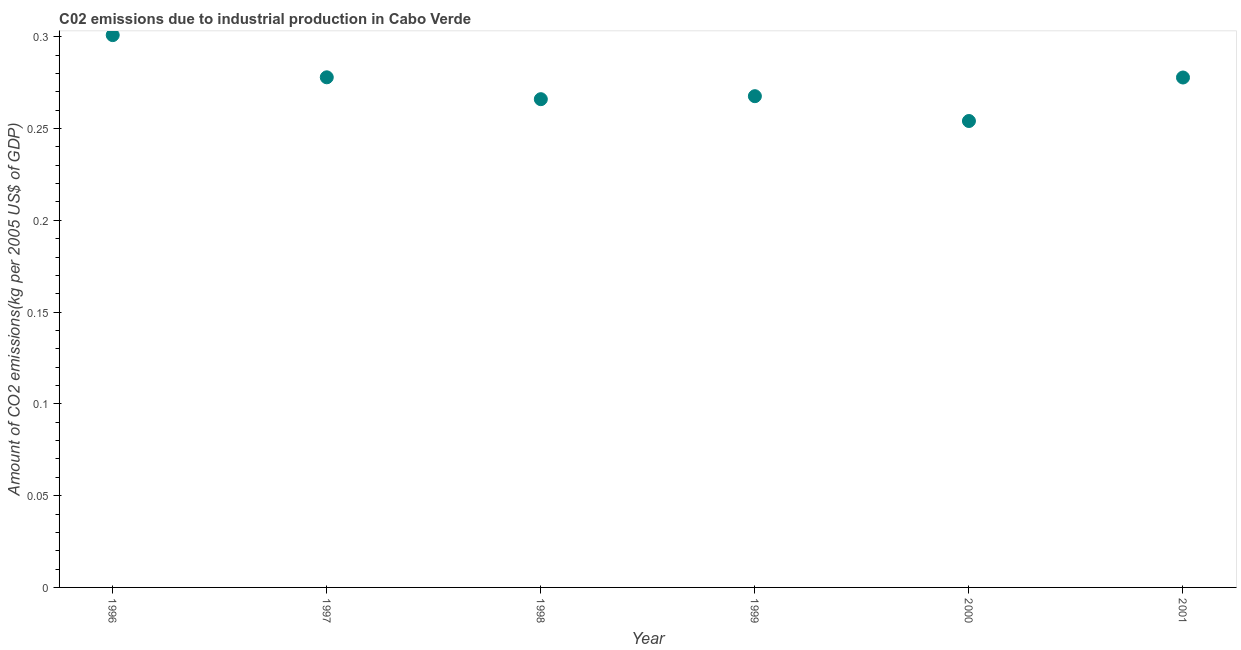What is the amount of co2 emissions in 2000?
Provide a short and direct response. 0.25. Across all years, what is the maximum amount of co2 emissions?
Make the answer very short. 0.3. Across all years, what is the minimum amount of co2 emissions?
Provide a short and direct response. 0.25. In which year was the amount of co2 emissions maximum?
Your answer should be very brief. 1996. In which year was the amount of co2 emissions minimum?
Your answer should be very brief. 2000. What is the sum of the amount of co2 emissions?
Give a very brief answer. 1.64. What is the difference between the amount of co2 emissions in 1996 and 1998?
Give a very brief answer. 0.03. What is the average amount of co2 emissions per year?
Offer a very short reply. 0.27. What is the median amount of co2 emissions?
Make the answer very short. 0.27. In how many years, is the amount of co2 emissions greater than 0.17 kg per 2005 US$ of GDP?
Give a very brief answer. 6. Do a majority of the years between 1997 and 1996 (inclusive) have amount of co2 emissions greater than 0.24000000000000002 kg per 2005 US$ of GDP?
Offer a very short reply. No. What is the ratio of the amount of co2 emissions in 1997 to that in 1999?
Offer a very short reply. 1.04. Is the amount of co2 emissions in 1996 less than that in 1998?
Your response must be concise. No. Is the difference between the amount of co2 emissions in 1998 and 1999 greater than the difference between any two years?
Keep it short and to the point. No. What is the difference between the highest and the second highest amount of co2 emissions?
Your response must be concise. 0.02. What is the difference between the highest and the lowest amount of co2 emissions?
Offer a very short reply. 0.05. In how many years, is the amount of co2 emissions greater than the average amount of co2 emissions taken over all years?
Keep it short and to the point. 3. Does the amount of co2 emissions monotonically increase over the years?
Offer a very short reply. No. How many dotlines are there?
Offer a very short reply. 1. Does the graph contain any zero values?
Offer a terse response. No. What is the title of the graph?
Ensure brevity in your answer.  C02 emissions due to industrial production in Cabo Verde. What is the label or title of the X-axis?
Your response must be concise. Year. What is the label or title of the Y-axis?
Offer a very short reply. Amount of CO2 emissions(kg per 2005 US$ of GDP). What is the Amount of CO2 emissions(kg per 2005 US$ of GDP) in 1996?
Your answer should be compact. 0.3. What is the Amount of CO2 emissions(kg per 2005 US$ of GDP) in 1997?
Give a very brief answer. 0.28. What is the Amount of CO2 emissions(kg per 2005 US$ of GDP) in 1998?
Make the answer very short. 0.27. What is the Amount of CO2 emissions(kg per 2005 US$ of GDP) in 1999?
Offer a terse response. 0.27. What is the Amount of CO2 emissions(kg per 2005 US$ of GDP) in 2000?
Provide a short and direct response. 0.25. What is the Amount of CO2 emissions(kg per 2005 US$ of GDP) in 2001?
Your answer should be very brief. 0.28. What is the difference between the Amount of CO2 emissions(kg per 2005 US$ of GDP) in 1996 and 1997?
Keep it short and to the point. 0.02. What is the difference between the Amount of CO2 emissions(kg per 2005 US$ of GDP) in 1996 and 1998?
Keep it short and to the point. 0.03. What is the difference between the Amount of CO2 emissions(kg per 2005 US$ of GDP) in 1996 and 1999?
Your response must be concise. 0.03. What is the difference between the Amount of CO2 emissions(kg per 2005 US$ of GDP) in 1996 and 2000?
Your answer should be very brief. 0.05. What is the difference between the Amount of CO2 emissions(kg per 2005 US$ of GDP) in 1996 and 2001?
Your response must be concise. 0.02. What is the difference between the Amount of CO2 emissions(kg per 2005 US$ of GDP) in 1997 and 1998?
Provide a short and direct response. 0.01. What is the difference between the Amount of CO2 emissions(kg per 2005 US$ of GDP) in 1997 and 1999?
Give a very brief answer. 0.01. What is the difference between the Amount of CO2 emissions(kg per 2005 US$ of GDP) in 1997 and 2000?
Provide a succinct answer. 0.02. What is the difference between the Amount of CO2 emissions(kg per 2005 US$ of GDP) in 1997 and 2001?
Provide a short and direct response. 0. What is the difference between the Amount of CO2 emissions(kg per 2005 US$ of GDP) in 1998 and 1999?
Offer a very short reply. -0. What is the difference between the Amount of CO2 emissions(kg per 2005 US$ of GDP) in 1998 and 2000?
Keep it short and to the point. 0.01. What is the difference between the Amount of CO2 emissions(kg per 2005 US$ of GDP) in 1998 and 2001?
Offer a terse response. -0.01. What is the difference between the Amount of CO2 emissions(kg per 2005 US$ of GDP) in 1999 and 2000?
Ensure brevity in your answer.  0.01. What is the difference between the Amount of CO2 emissions(kg per 2005 US$ of GDP) in 1999 and 2001?
Ensure brevity in your answer.  -0.01. What is the difference between the Amount of CO2 emissions(kg per 2005 US$ of GDP) in 2000 and 2001?
Offer a terse response. -0.02. What is the ratio of the Amount of CO2 emissions(kg per 2005 US$ of GDP) in 1996 to that in 1997?
Your answer should be compact. 1.08. What is the ratio of the Amount of CO2 emissions(kg per 2005 US$ of GDP) in 1996 to that in 1998?
Your response must be concise. 1.13. What is the ratio of the Amount of CO2 emissions(kg per 2005 US$ of GDP) in 1996 to that in 1999?
Keep it short and to the point. 1.12. What is the ratio of the Amount of CO2 emissions(kg per 2005 US$ of GDP) in 1996 to that in 2000?
Provide a succinct answer. 1.18. What is the ratio of the Amount of CO2 emissions(kg per 2005 US$ of GDP) in 1996 to that in 2001?
Your response must be concise. 1.08. What is the ratio of the Amount of CO2 emissions(kg per 2005 US$ of GDP) in 1997 to that in 1998?
Make the answer very short. 1.04. What is the ratio of the Amount of CO2 emissions(kg per 2005 US$ of GDP) in 1997 to that in 1999?
Your answer should be very brief. 1.04. What is the ratio of the Amount of CO2 emissions(kg per 2005 US$ of GDP) in 1997 to that in 2000?
Your answer should be very brief. 1.09. What is the ratio of the Amount of CO2 emissions(kg per 2005 US$ of GDP) in 1998 to that in 1999?
Your response must be concise. 0.99. What is the ratio of the Amount of CO2 emissions(kg per 2005 US$ of GDP) in 1998 to that in 2000?
Offer a terse response. 1.05. What is the ratio of the Amount of CO2 emissions(kg per 2005 US$ of GDP) in 1998 to that in 2001?
Give a very brief answer. 0.96. What is the ratio of the Amount of CO2 emissions(kg per 2005 US$ of GDP) in 1999 to that in 2000?
Ensure brevity in your answer.  1.05. What is the ratio of the Amount of CO2 emissions(kg per 2005 US$ of GDP) in 1999 to that in 2001?
Your answer should be very brief. 0.96. What is the ratio of the Amount of CO2 emissions(kg per 2005 US$ of GDP) in 2000 to that in 2001?
Your answer should be compact. 0.92. 